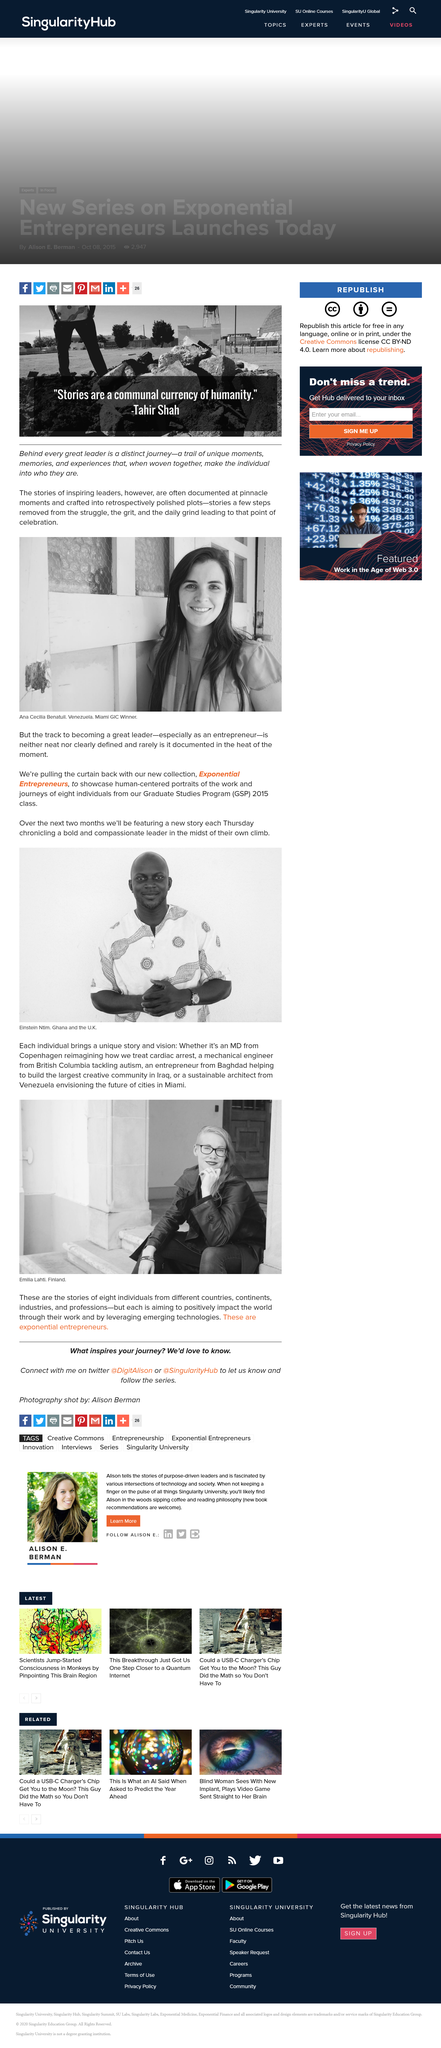Identify some key points in this picture. Ana won the Miami GIC. The woman in the photo is Ana Cecilla Benatuit. New stories are released on Thursdays. Eight individuals from the Graduate Studies Program are featured. The person in the photo is wearing a watch. 